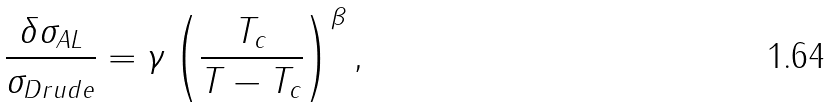Convert formula to latex. <formula><loc_0><loc_0><loc_500><loc_500>\frac { \delta \sigma _ { A L } } { \sigma _ { D r u d e } } = \gamma \left ( \frac { T _ { c } } { T - T _ { c } } \right ) ^ { \beta } ,</formula> 